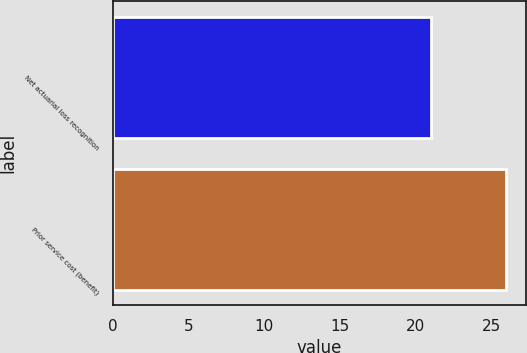Convert chart to OTSL. <chart><loc_0><loc_0><loc_500><loc_500><bar_chart><fcel>Net actuarial loss recognition<fcel>Prior service cost (benefit)<nl><fcel>21<fcel>26<nl></chart> 